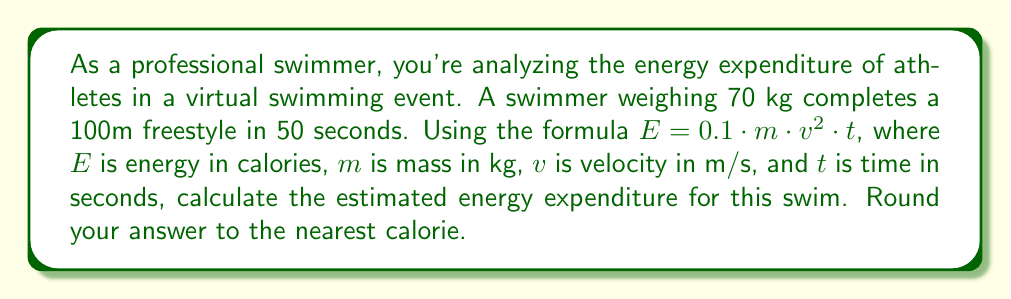Provide a solution to this math problem. To solve this problem, we'll follow these steps:

1. Calculate the swimmer's velocity:
   Distance = 100 m, Time = 50 s
   $v = \frac{distance}{time} = \frac{100}{50} = 2$ m/s

2. Identify the known values:
   $m = 70$ kg
   $v = 2$ m/s
   $t = 50$ s

3. Apply the formula:
   $E = 0.1 \cdot m \cdot v^2 \cdot t$
   $E = 0.1 \cdot 70 \cdot 2^2 \cdot 50$

4. Calculate:
   $E = 0.1 \cdot 70 \cdot 4 \cdot 50$
   $E = 1400$ calories

5. Round to the nearest calorie:
   $E \approx 1400$ calories
Answer: 1400 calories 